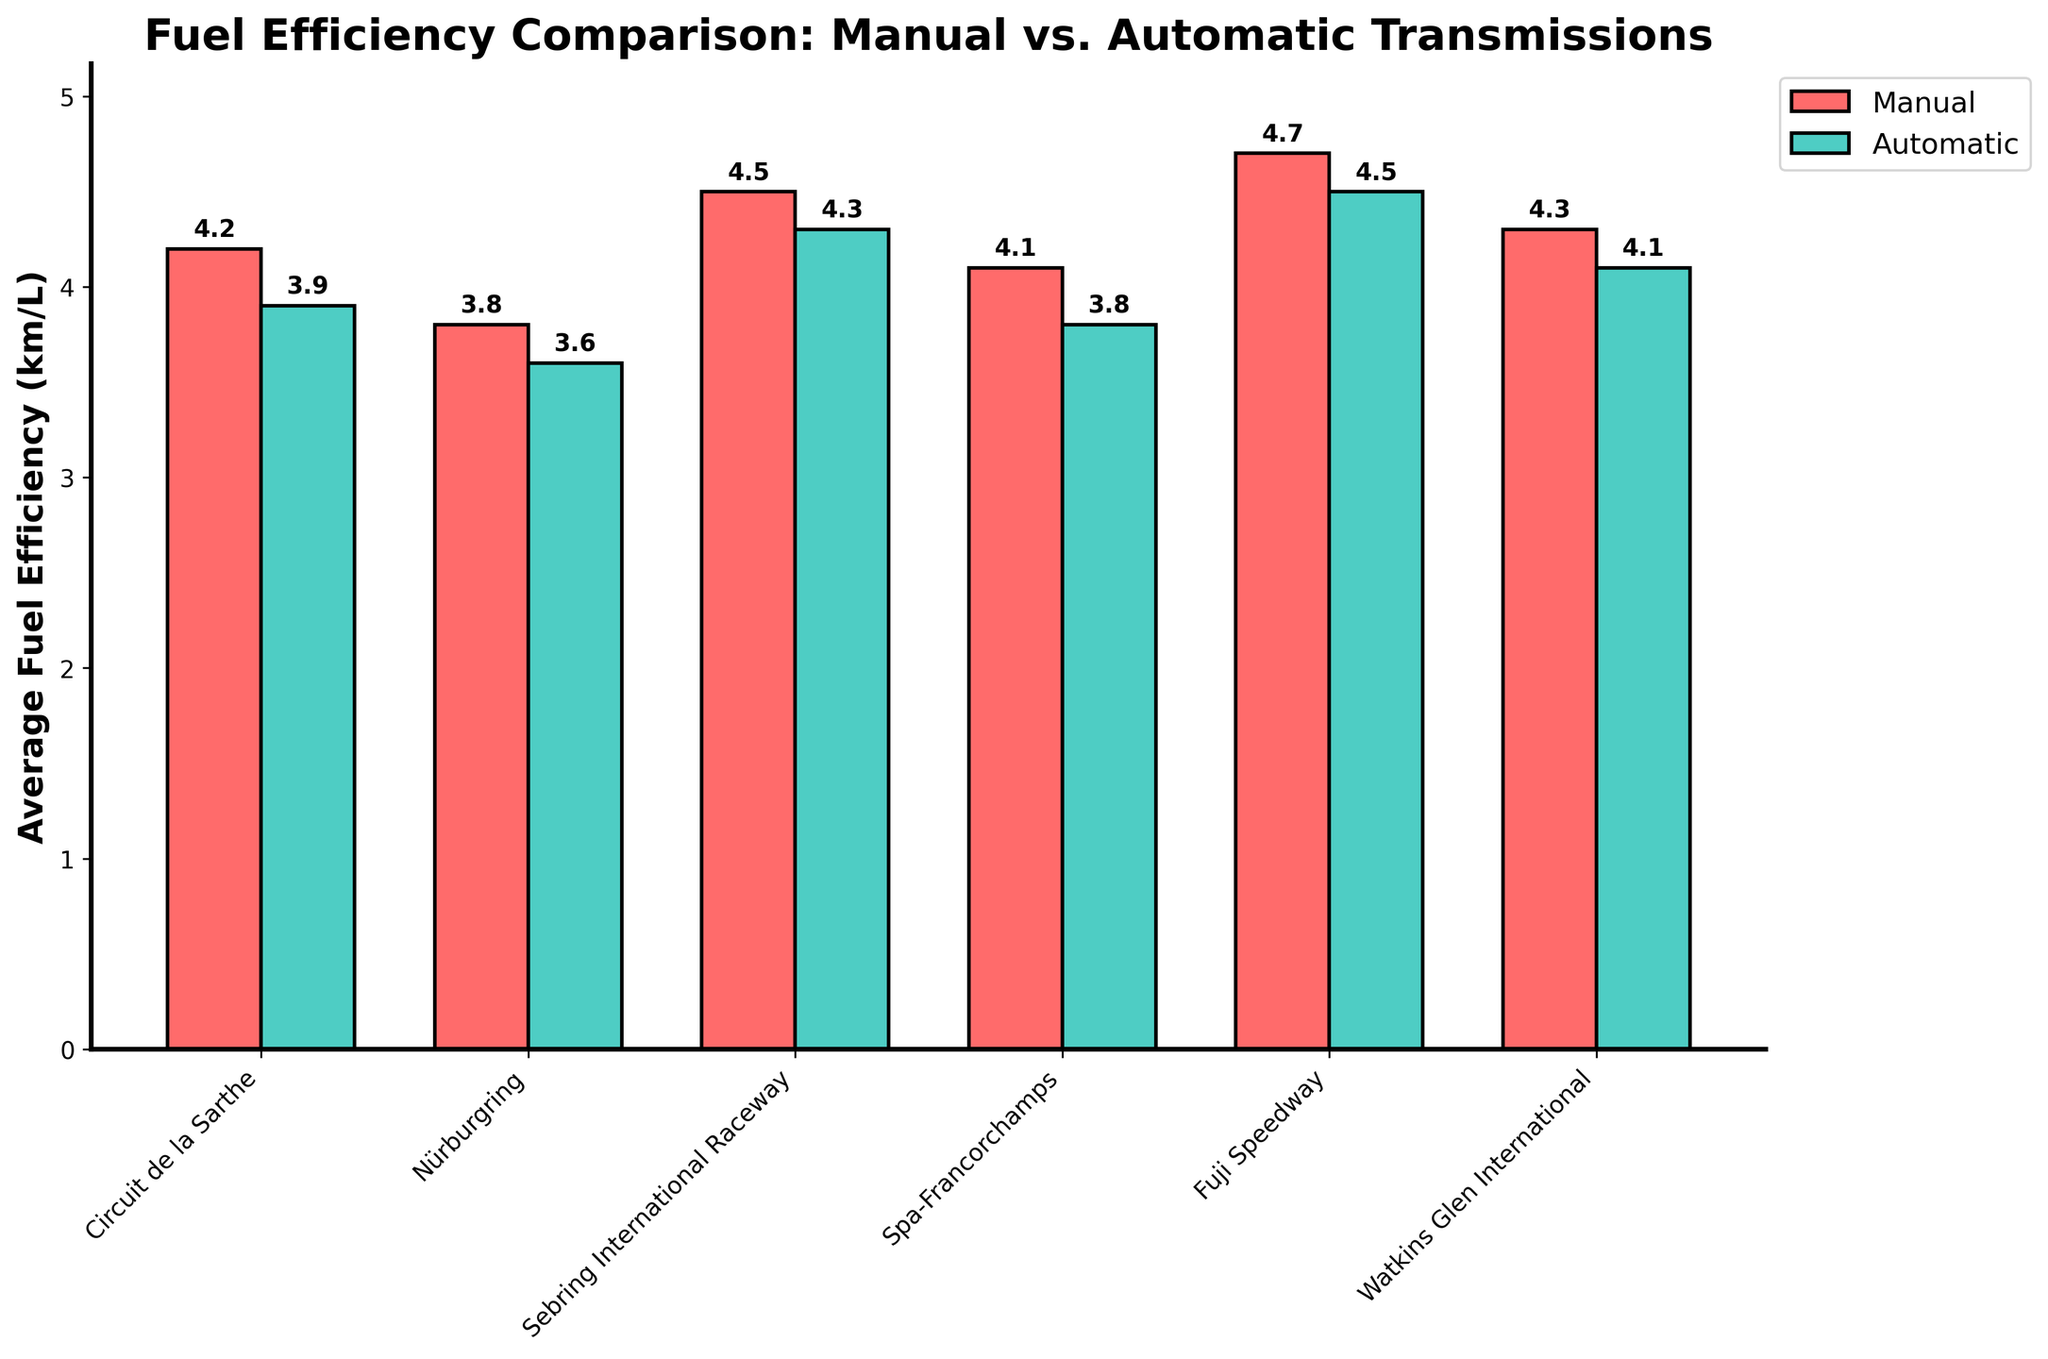What is the average fuel efficiency for Manual transmissions across all tracks? First, note the manual fuel efficiencies for all tracks: 4.2, 3.8, 4.5, 4.1, 4.7, 4.3. Sum these values (4.2 + 3.8 + 4.5 + 4.1 + 4.7 + 4.3 = 25.6). Divide by the number of tracks (6) to get the average: 25.6 / 6 = 4.27.
Answer: 4.27 Which transmission type has higher fuel efficiency at Circuit de la Sarthe? Compare the fuel efficiency values for Manual (4.2 km/L) and Automatic (3.9 km/L) at Circuit de la Sarthe. Manual is higher.
Answer: Manual By how much does the fuel efficiency of Automatic transmissions at Nürburgring differ from that at Spa-Francorchamps? Note the Automatic fuel efficiencies for Nürburgring (3.6) and Spa-Francorchamps (3.8). Calculate the difference: 3.8 - 3.6 = 0.2.
Answer: 0.2 Which track shows the largest difference in fuel efficiency between Manual and Automatic transmissions? Calculate the differences for each track and compare: Circuit de la Sarthe (4.2 - 3.9 = 0.3), Nürburgring (3.8 - 3.6 = 0.2), Sebring International Raceway (4.5 - 4.3 = 0.2), Spa-Francorchamps (4.1 - 3.8 = 0.3), Fuji Speedway (4.7 - 4.5 = 0.2), Watkins Glen International (4.3 - 4.1 = 0.2). Spa-Francorchamps and Circuit de la Sarthe have the largest difference (0.3).
Answer: Spa-Francorchamps and Circuit de la Sarthe What is the total combined fuel efficiency for Manual transmissions across Nürburgring and Sebring International Raceway? Add the fuel efficiencies for Manual transmissions at Nürburgring (3.8) and Sebring International Raceway (4.5): 3.8 + 4.5 = 8.3.
Answer: 8.3 Which track has the highest average fuel efficiency for both transmission types combined? Calculate the combined average fuel efficiency for both transmission types at each track: Circuit de la Sarthe (4.2 + 3.9)/2 = 4.05, Nürburgring (3.8 + 3.6)/2 = 3.7, Sebring International Raceway (4.5 + 4.3)/2 = 4.4, Spa-Francorchamps (4.1 + 3.8)/2 = 3.95, Fuji Speedway (4.7 + 4.5)/2 = 4.6, Watkins Glen International (4.3 + 4.1)/2 = 4.2. Fuji Speedway has the highest average (4.6).
Answer: Fuji Speedway At which track is the fuel efficiency of Automatic transmissions exactly 3.8 km/L? Identify the track where the Automatic fuel efficiency is 3.8 km/L. This occurs at Spa-Francorchamps.
Answer: Spa-Francorchamps On which tracks is the fuel efficiency for Manual transmissions greater than 4 km/L? Identify the tracks where Manual fuel efficiency is greater than 4 km/L: Circuit de la Sarthe (4.2), Sebring International Raceway (4.5), Spa-Francorchamps (4.1), Fuji Speedway (4.7), Watkins Glen International (4.3).
Answer: Circuit de la Sarthe, Sebring International Raceway, Spa-Francorchamps, Fuji Speedway, Watkins Glen International 